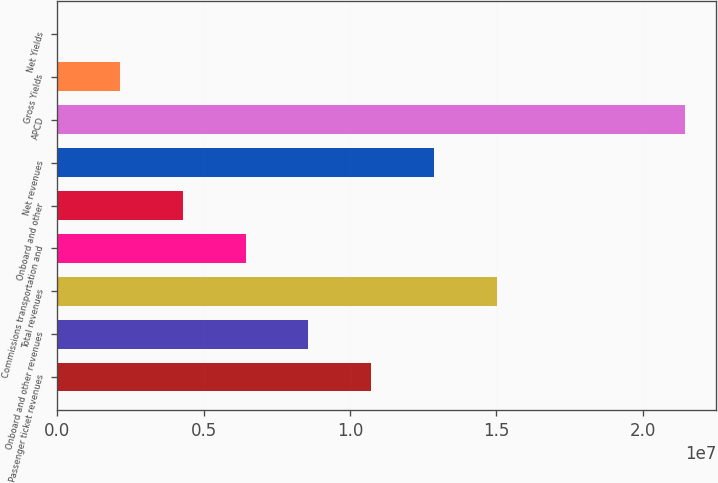<chart> <loc_0><loc_0><loc_500><loc_500><bar_chart><fcel>Passenger ticket revenues<fcel>Onboard and other revenues<fcel>Total revenues<fcel>Commissions transportation and<fcel>Onboard and other<fcel>Net revenues<fcel>APCD<fcel>Gross Yields<fcel>Net Yields<nl><fcel>1.07197e+07<fcel>8.57581e+06<fcel>1.50075e+07<fcel>6.4319e+06<fcel>4.28799e+06<fcel>1.28636e+07<fcel>2.14393e+07<fcel>2.14407e+06<fcel>160.1<nl></chart> 